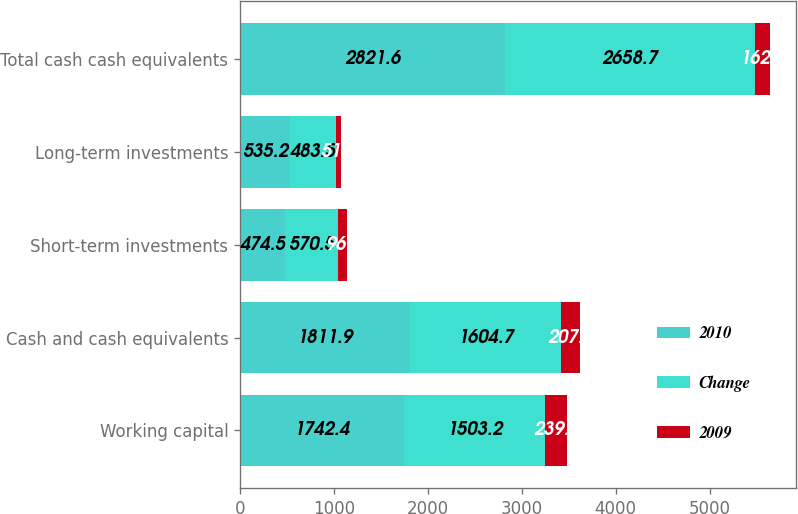<chart> <loc_0><loc_0><loc_500><loc_500><stacked_bar_chart><ecel><fcel>Working capital<fcel>Cash and cash equivalents<fcel>Short-term investments<fcel>Long-term investments<fcel>Total cash cash equivalents<nl><fcel>2010<fcel>1742.4<fcel>1811.9<fcel>474.5<fcel>535.2<fcel>2821.6<nl><fcel>Change<fcel>1503.2<fcel>1604.7<fcel>570.5<fcel>483.5<fcel>2658.7<nl><fcel>2009<fcel>239.2<fcel>207.2<fcel>96<fcel>51.7<fcel>162.9<nl></chart> 